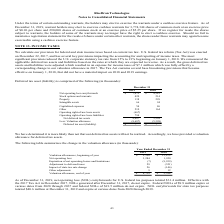From Ricebran Technologies's financial document, What are the respective valuation allowances at the beginning of the year in 2018 and 2019? The document shows two values: $13,872 and $5,398 (in thousands). From the document: "Net deferred tax assets 8,687 5,398 Vaulation allowances, beginning of year 5,398 $ 13,872 $..." Also, What are the respective net operating loss in 2018 and 2019? The document shows two values: 1,920 and 3,284 (in thousands). From the document: "Net operating loss 3,284 1,920 Net operating loss 3,284 1,920..." Also, What are the respective valuation allowances at the end of the year in 2018 and 2019? The document shows two values: $5,398 and $8,739 (in thousands). From the document: "Net deferred tax assets 8,687 5,398 Valuation allowance, end of year 8,739 $ 5,398 $..." Also, can you calculate: What is the change in valuation allowance in 2019? Based on the calculation: 8,739 - 5,398 , the result is 3341 (in thousands). This is based on the information: "Net deferred tax assets 8,687 5,398 Valuation allowance, end of year 8,739 $ 5,398 $..." The key data points involved are: 5,398, 8,739. Also, can you calculate: What is the change in valuation allowance in 2018? Based on the calculation: 5,398 - 13,872 , the result is -8474 (in thousands). This is based on the information: "Vaulation allowances, beginning of year 5,398 $ 13,872 $ Net deferred tax assets 8,687 5,398..." The key data points involved are: 13,872, 5,398. Also, can you calculate: What is the change in net operating loss between 2018 and 2019? Based on the calculation: 3,284 - 1,920 , the result is 1364 (in thousands). This is based on the information: "Net operating loss 3,284 1,920 Net operating loss 3,284 1,920..." The key data points involved are: 1,920, 3,284. 